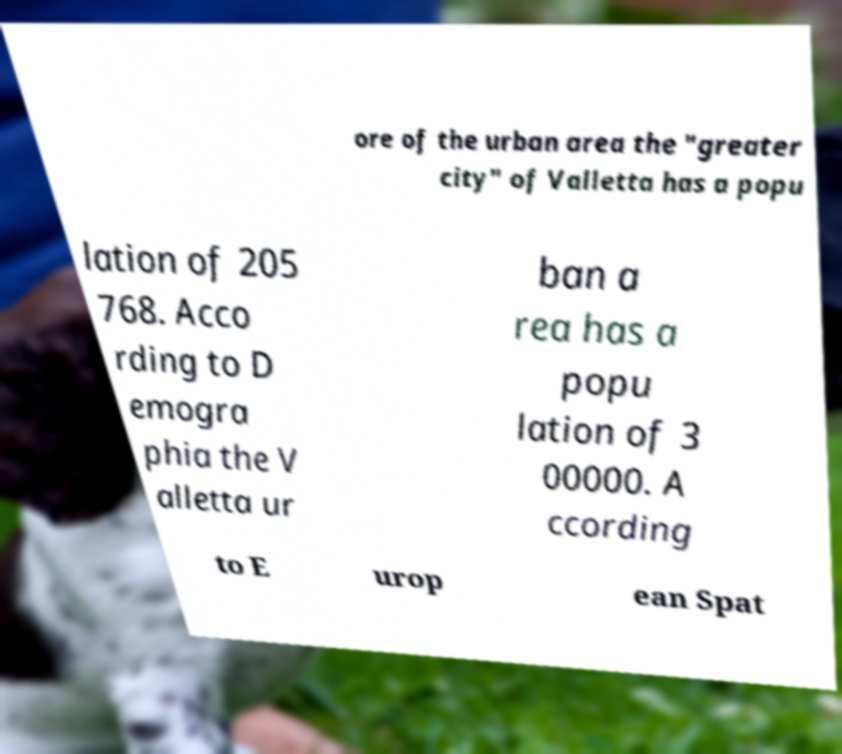For documentation purposes, I need the text within this image transcribed. Could you provide that? ore of the urban area the "greater city" of Valletta has a popu lation of 205 768. Acco rding to D emogra phia the V alletta ur ban a rea has a popu lation of 3 00000. A ccording to E urop ean Spat 